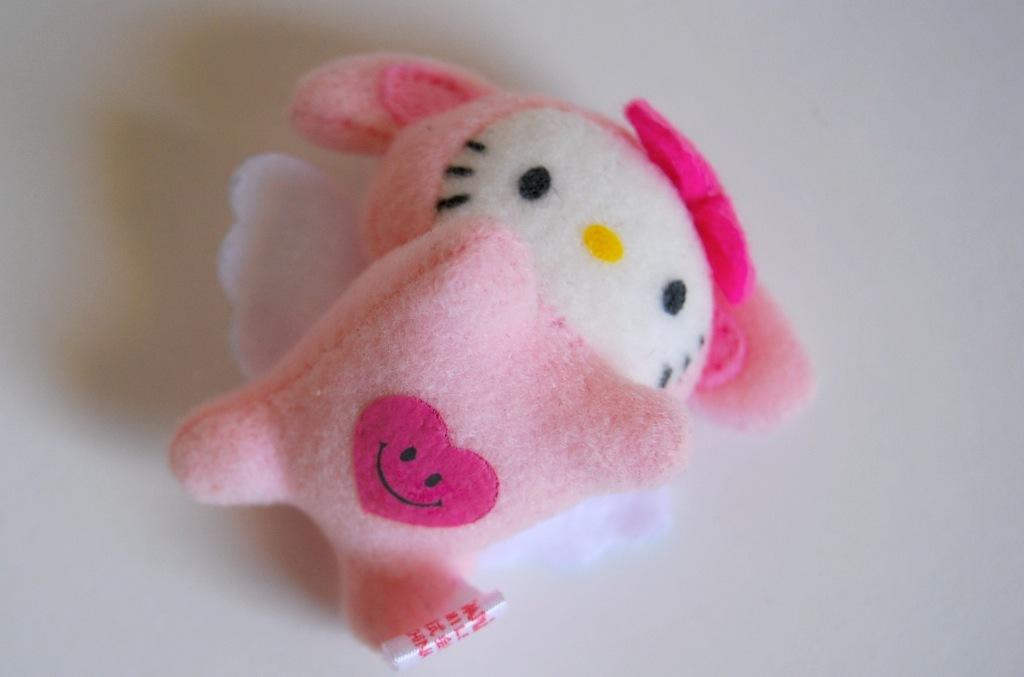What is the main subject of the image? There is a doll in the image. What color is the doll? The doll is pink in color. What can be seen in the background of the image? The background of the image is white. What type of cough does the doll have in the image? There is no indication of a cough in the image, as the doll is an inanimate object. 